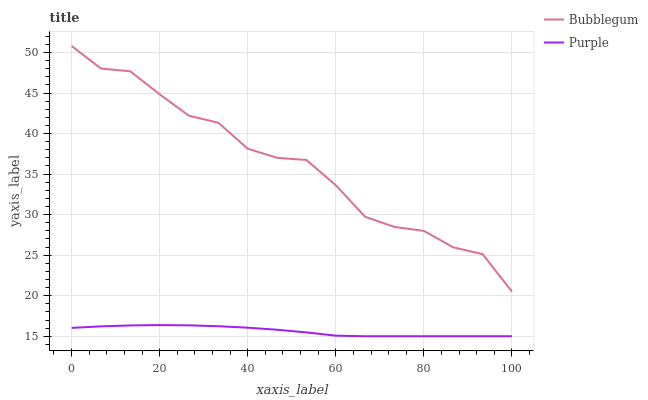Does Bubblegum have the minimum area under the curve?
Answer yes or no. No. Is Bubblegum the smoothest?
Answer yes or no. No. Does Bubblegum have the lowest value?
Answer yes or no. No. Is Purple less than Bubblegum?
Answer yes or no. Yes. Is Bubblegum greater than Purple?
Answer yes or no. Yes. Does Purple intersect Bubblegum?
Answer yes or no. No. 